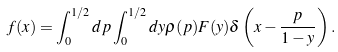<formula> <loc_0><loc_0><loc_500><loc_500>f ( x ) = \int _ { 0 } ^ { 1 / 2 } d p \int _ { 0 } ^ { 1 / 2 } d y \rho ( p ) F ( y ) \delta \left ( x - \frac { p } { 1 - y } \right ) .</formula> 